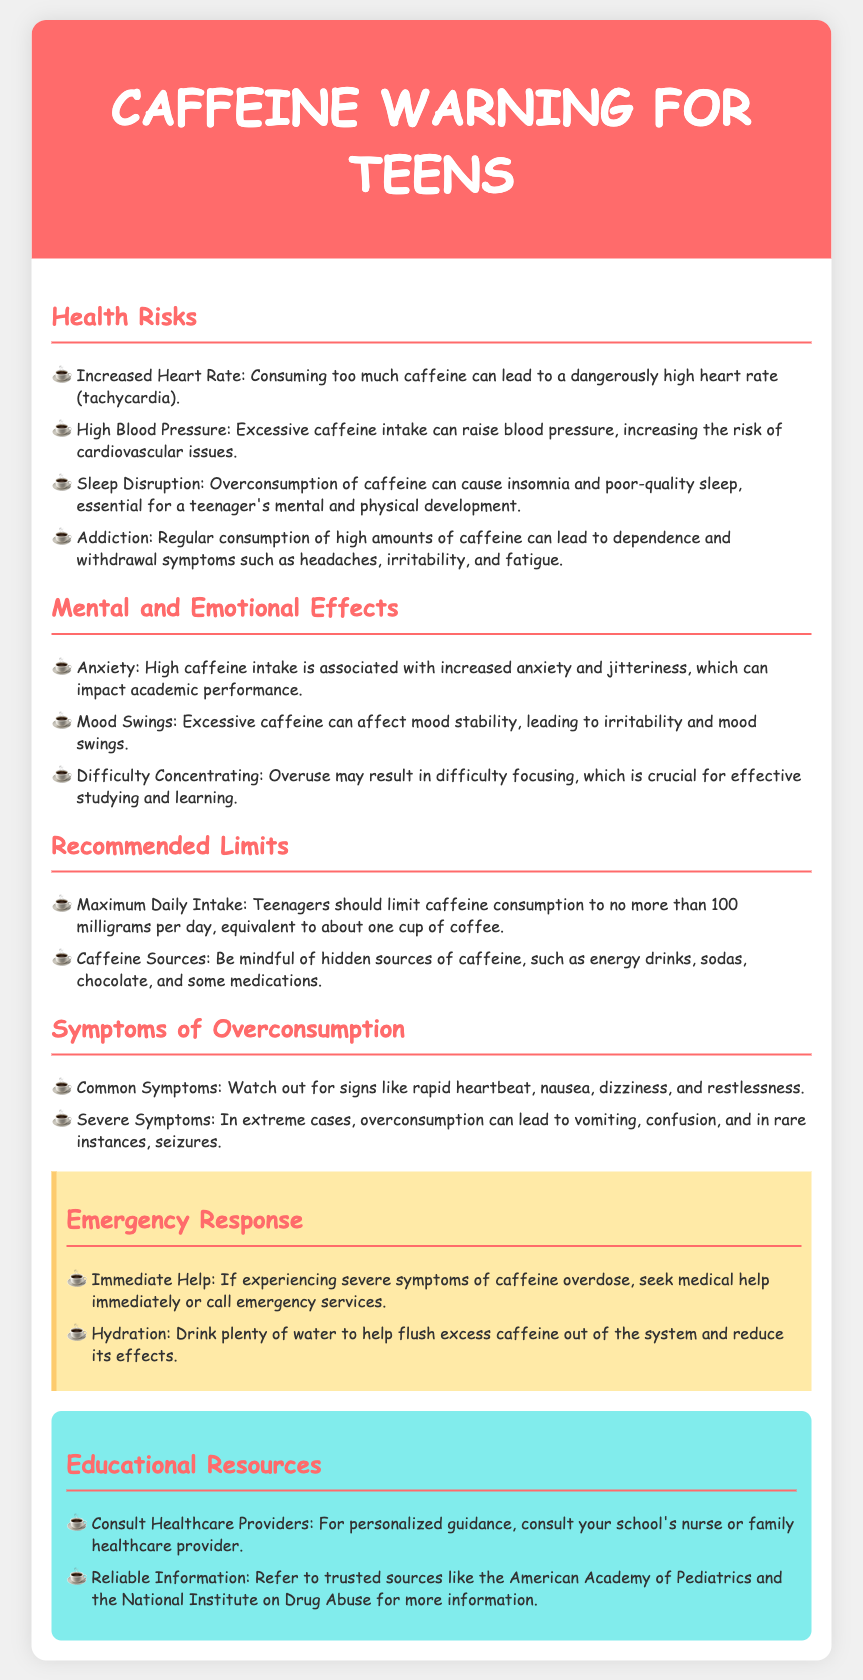What is the maximum daily intake of caffeine for teenagers? The document states that teenagers should limit caffeine consumption to no more than 100 milligrams per day.
Answer: 100 milligrams What symptoms might indicate caffeine overconsumption? The document lists symptoms such as rapid heartbeat, nausea, dizziness, and restlessness as common signs of overconsumption.
Answer: Rapid heartbeat, nausea, dizziness, restlessness What is a severe symptom of caffeine overdose mentioned? Severe symptoms include vomiting, confusion, and in rare instances, seizures according to the document.
Answer: Vomiting What are two mental effects of high caffeine intake? The document states that high caffeine intake can lead to anxiety and mood swings.
Answer: Anxiety, mood swings What can help flush excess caffeine out of the system? The document recommends drinking plenty of water to help flush excess caffeine out of the body.
Answer: Water What should you do if experiencing severe symptoms of caffeine overdose? The document advises to seek medical help immediately or call emergency services if severe symptoms are present.
Answer: Seek medical help What are hidden sources of caffeine listed in the document? The document mentions energy drinks, sodas, chocolate, and some medications as hidden sources of caffeine.
Answer: Energy drinks, sodas, chocolate, medications What type of information can you consult for personalized guidance? The document suggests consulting your school's nurse or family healthcare provider for personalized guidance.
Answer: School's nurse or family healthcare provider What is one reliable source for more information about caffeine? The document states that the American Academy of Pediatrics is a trusted source for more information.
Answer: American Academy of Pediatrics 